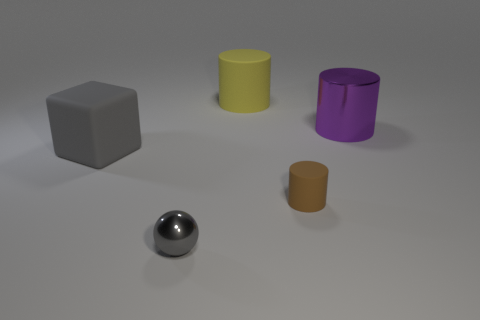What number of other things are made of the same material as the small cylinder?
Offer a very short reply. 2. What is the color of the big rubber object that is in front of the metal cylinder that is behind the gray thing that is behind the tiny cylinder?
Your response must be concise. Gray. What is the material of the purple thing that is the same size as the cube?
Give a very brief answer. Metal. What number of things are gray rubber cubes that are behind the tiny metal sphere or tiny cylinders?
Provide a succinct answer. 2. Are any tiny yellow rubber cylinders visible?
Offer a very short reply. No. There is a big cylinder to the left of the small brown rubber thing; what is its material?
Provide a succinct answer. Rubber. There is a large thing that is the same color as the tiny metal ball; what material is it?
Your answer should be compact. Rubber. How many small objects are gray metallic things or yellow rubber objects?
Give a very brief answer. 1. The big metallic cylinder has what color?
Give a very brief answer. Purple. Are there any gray spheres on the left side of the rubber cylinder that is in front of the purple cylinder?
Provide a short and direct response. Yes. 